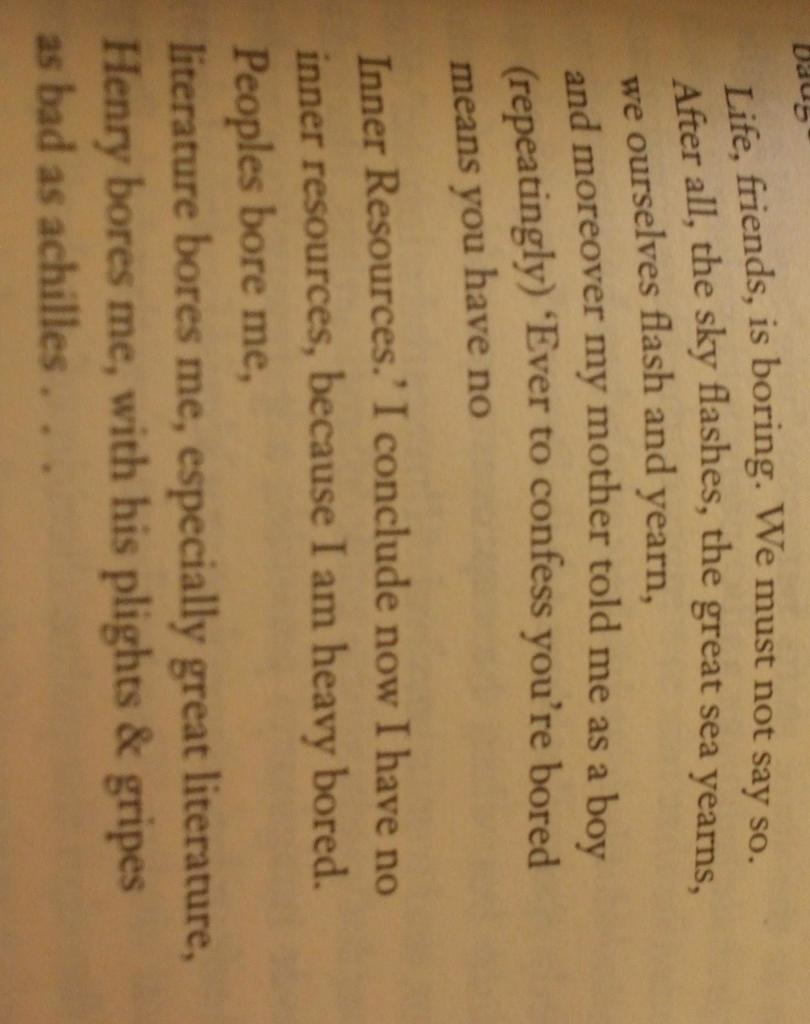<image>
Describe the image concisely. A page from a book in which the narrator discusses being bored with people and life. 